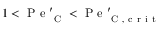Convert formula to latex. <formula><loc_0><loc_0><loc_500><loc_500>1 < P e _ { C } ^ { \prime } < P e _ { C , c r i t } ^ { \prime }</formula> 